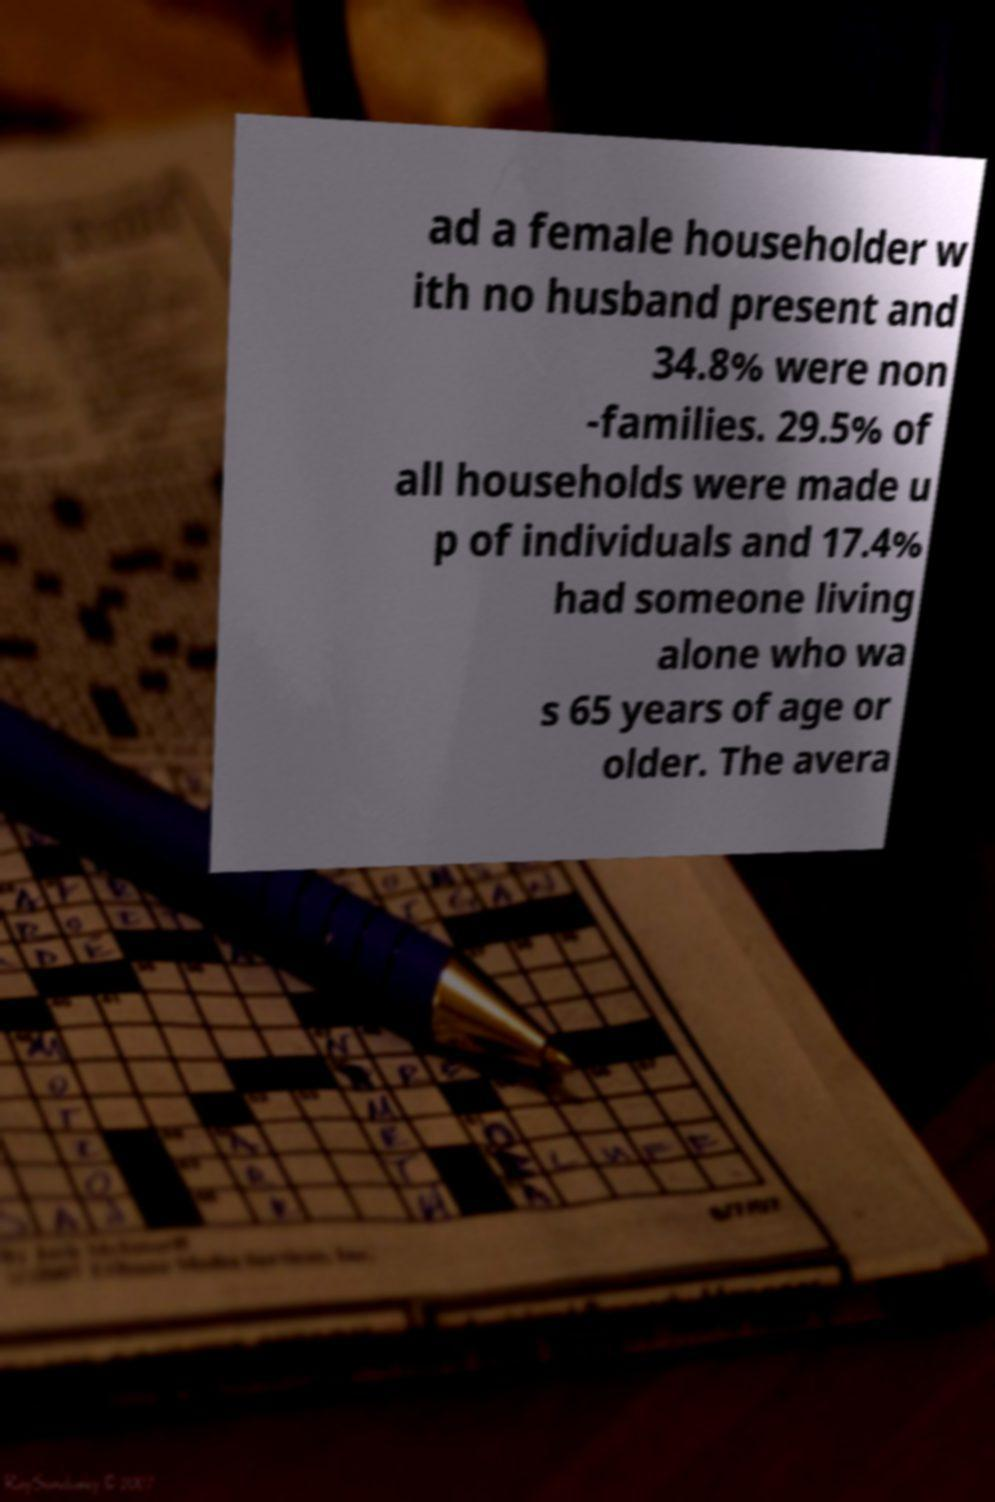Can you read and provide the text displayed in the image?This photo seems to have some interesting text. Can you extract and type it out for me? ad a female householder w ith no husband present and 34.8% were non -families. 29.5% of all households were made u p of individuals and 17.4% had someone living alone who wa s 65 years of age or older. The avera 